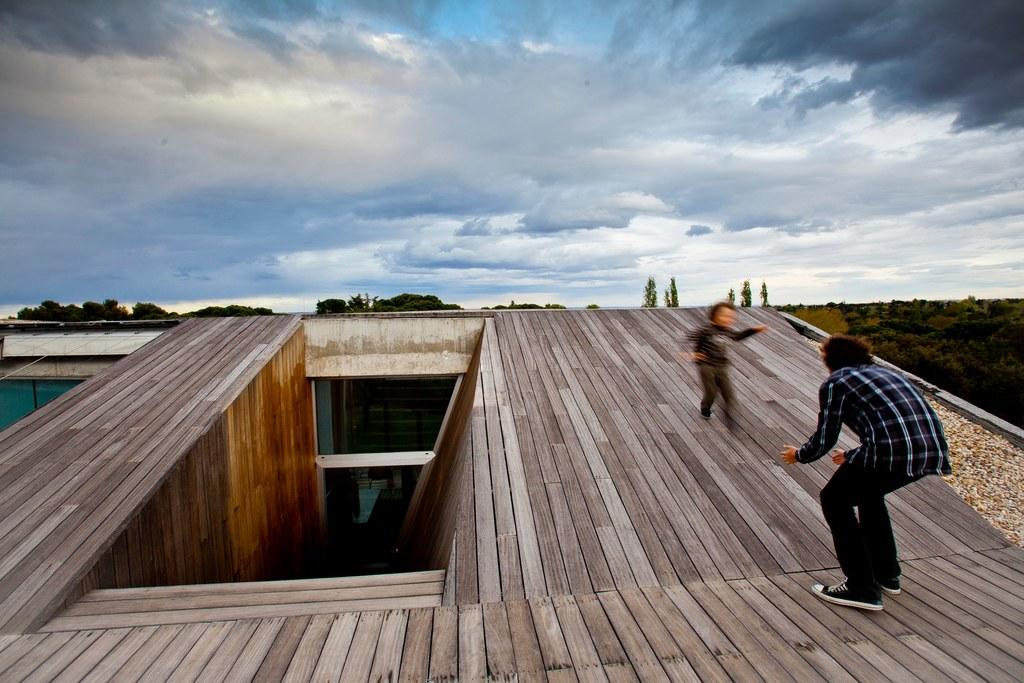What type of house is in the foreground of the picture? There is a wooden house in the foreground of the picture. What are the man and the kid doing in the image? The man and the kid are on top of the house. What can be seen in the center of the background of the image? There are trees in the center of the background. How would you describe the sky in the image? The sky is cloudy in the image. What street is the wooden house located on in the image? There is no street visible in the image, so it cannot be determined which street the wooden house is located on. 